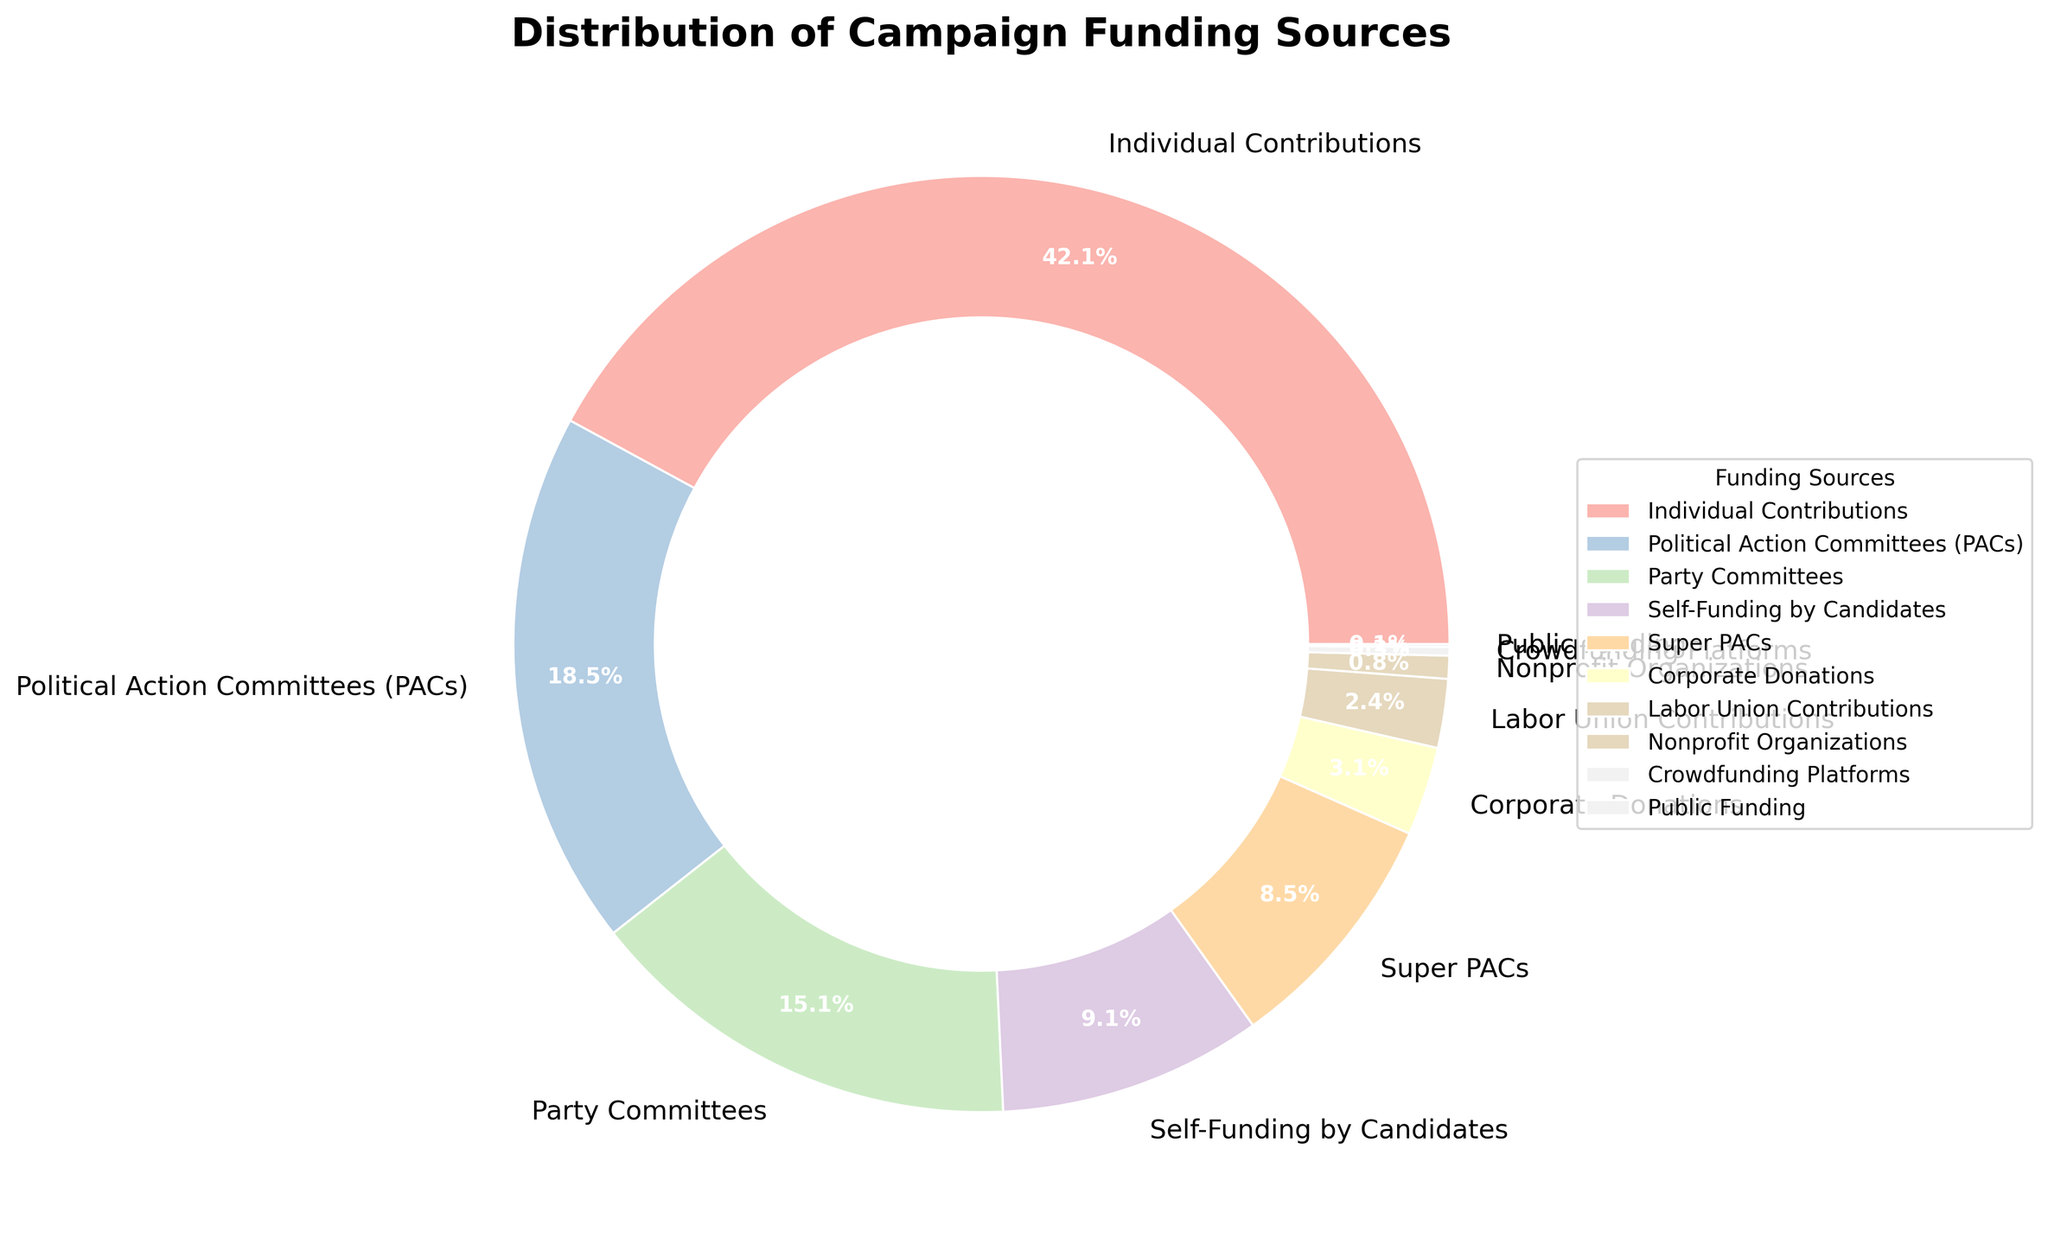What is the largest source of campaign funding shown in the figure? The largest portion of the pie chart, visually the biggest segment around the chart's circumference, represents 'Individual Contributions'.
Answer: Individual Contributions What is the combined percentage of funding from Political Action Committees (PACs) and Super PACs? Add the percentages for Political Action Committees (PACs) and Super PACs: 18.7% + 8.6% = 27.3%.
Answer: 27.3% Which funding source has a higher contribution, Self-Funding by Candidates or Corporate Donations? Compare the percentages directly: Self-Funding by Candidates is 9.2%, and Corporate Donations is 3.1%; 9.2% is greater than 3.1%.
Answer: Self-Funding by Candidates What percentage of funding comes from the combination of sources under 5%? Add the percentages of sources with less than 5%: Corporate Donations (3.1%), Labor Union Contributions (2.4%), Nonprofit Organizations (0.8%), Crowdfunding Platforms (0.3%), and Public Funding (0.1%). This sum is 3.1 + 2.4 + 0.8 + 0.3 + 0.1 = 6.7%.
Answer: 6.7% Visually identify which slice of the pie chart is the smallest. The smallest slice corresponds to Public Funding, represented by the visually tiniest segment.
Answer: Public Funding How much more significant is the Party Committees' funding percentage compared to Crowdfunding Platforms? Subtract Crowdfunding Platforms' percentage from Party Committees' percentage: 15.3% - 0.3% = 15.0%.
Answer: 15.0% If you were to combine Corporate and Labor Union Contributions, how would their total percentage compare to Super PACs? Sum Corporate Donations and Labor Union Contributions first: 3.1% + 2.4% = 5.5%. Then compare with Super PACs' percentage of 8.6%.
Answer: Less What fraction of total funding is from Individual Contributions, and what is its visual representation? Individual Contributions constitute 42.5% of the total, which visually is roughly a little under half of the pie chart.
Answer: 42.5% When combining contributions from Individual Contributions, Political Action Committees (PACs), and Party Committees, what fraction of the total does this represent? Sum these percentages: 42.5% + 18.7% + 15.3% = 76.5%.
Answer: 76.5% Is the percentage of funding from Public Funding visible on the chart's legend? Yes, the legend includes all sources listed, including Public Funding, which accounts for 0.1%.
Answer: Yes 